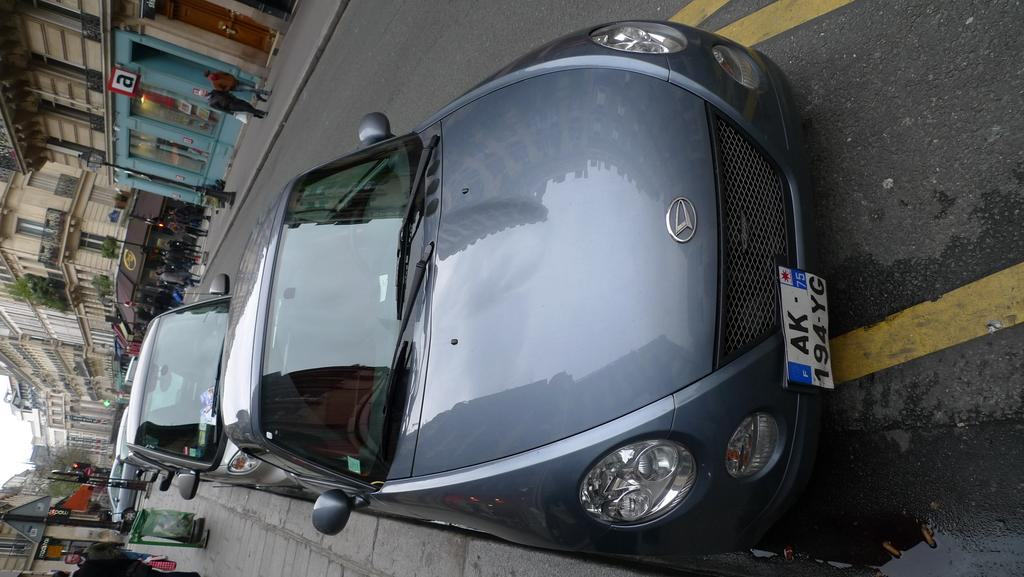<image>
Render a clear and concise summary of the photo. A parked car with license plate 194 YG. 